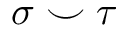Convert formula to latex. <formula><loc_0><loc_0><loc_500><loc_500>\sigma \smile \tau</formula> 